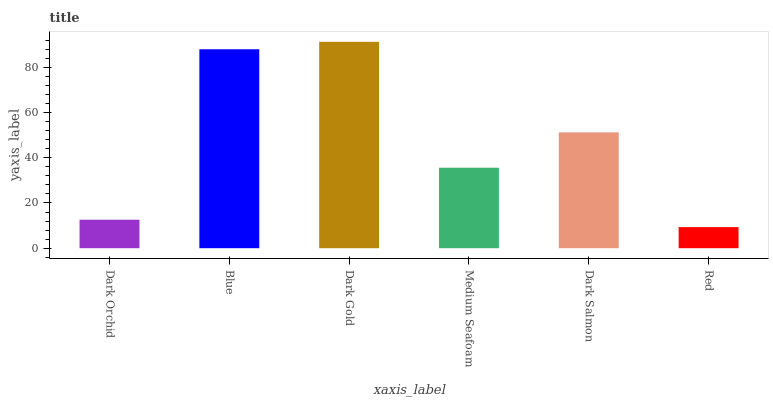Is Blue the minimum?
Answer yes or no. No. Is Blue the maximum?
Answer yes or no. No. Is Blue greater than Dark Orchid?
Answer yes or no. Yes. Is Dark Orchid less than Blue?
Answer yes or no. Yes. Is Dark Orchid greater than Blue?
Answer yes or no. No. Is Blue less than Dark Orchid?
Answer yes or no. No. Is Dark Salmon the high median?
Answer yes or no. Yes. Is Medium Seafoam the low median?
Answer yes or no. Yes. Is Dark Orchid the high median?
Answer yes or no. No. Is Blue the low median?
Answer yes or no. No. 